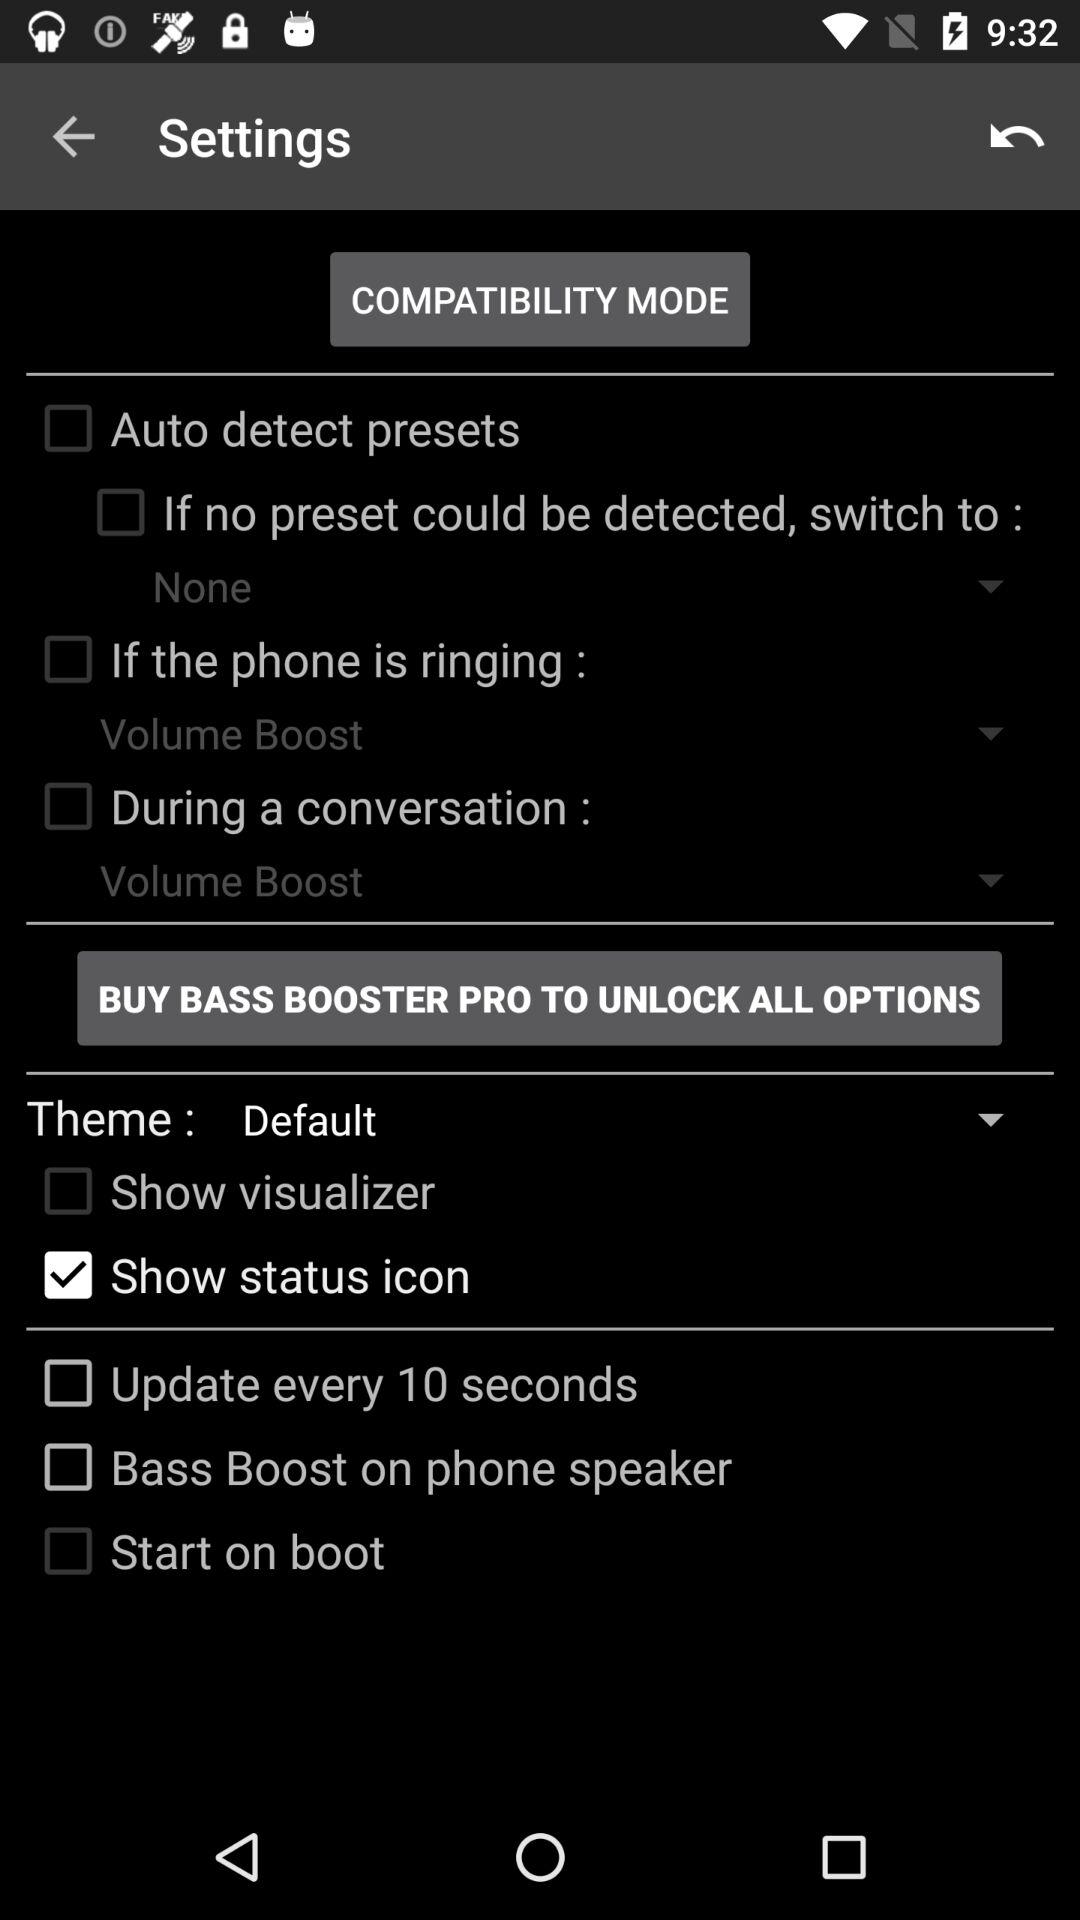What is the status of "Show status icon"? The status is "on". 